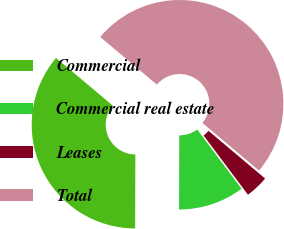Convert chart. <chart><loc_0><loc_0><loc_500><loc_500><pie_chart><fcel>Commercial<fcel>Commercial real estate<fcel>Leases<fcel>Total<nl><fcel>36.08%<fcel>10.28%<fcel>3.63%<fcel>50.0%<nl></chart> 